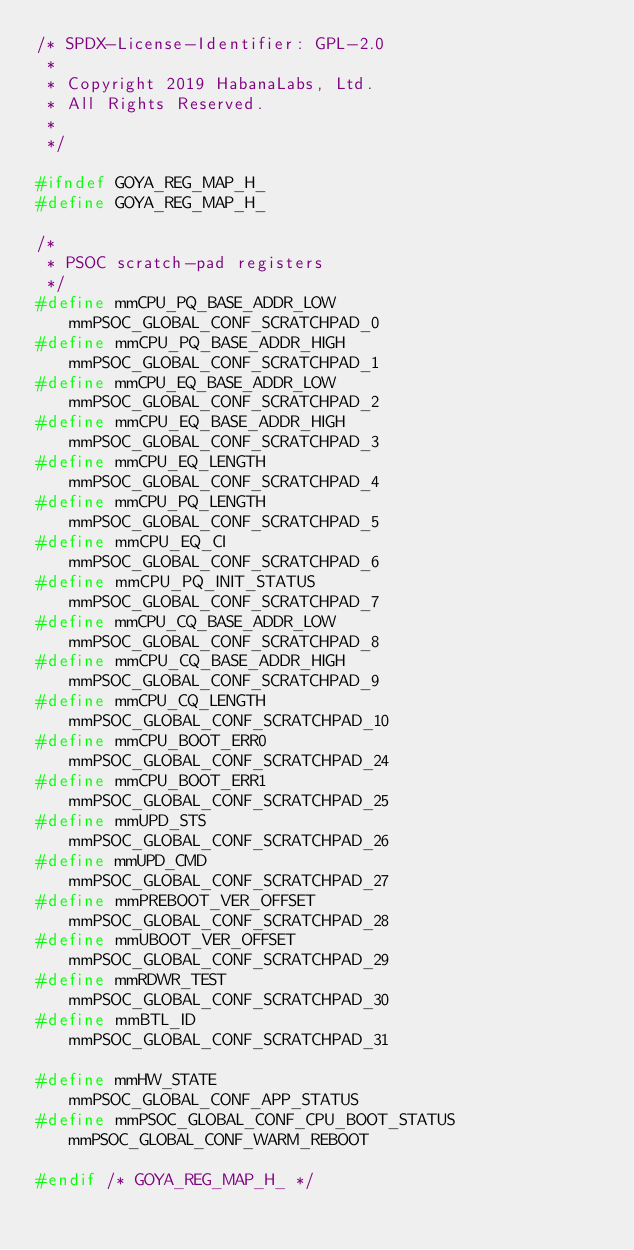<code> <loc_0><loc_0><loc_500><loc_500><_C_>/* SPDX-License-Identifier: GPL-2.0
 *
 * Copyright 2019 HabanaLabs, Ltd.
 * All Rights Reserved.
 *
 */

#ifndef GOYA_REG_MAP_H_
#define GOYA_REG_MAP_H_

/*
 * PSOC scratch-pad registers
 */
#define mmCPU_PQ_BASE_ADDR_LOW			mmPSOC_GLOBAL_CONF_SCRATCHPAD_0
#define mmCPU_PQ_BASE_ADDR_HIGH			mmPSOC_GLOBAL_CONF_SCRATCHPAD_1
#define mmCPU_EQ_BASE_ADDR_LOW			mmPSOC_GLOBAL_CONF_SCRATCHPAD_2
#define mmCPU_EQ_BASE_ADDR_HIGH			mmPSOC_GLOBAL_CONF_SCRATCHPAD_3
#define mmCPU_EQ_LENGTH				mmPSOC_GLOBAL_CONF_SCRATCHPAD_4
#define mmCPU_PQ_LENGTH				mmPSOC_GLOBAL_CONF_SCRATCHPAD_5
#define mmCPU_EQ_CI				mmPSOC_GLOBAL_CONF_SCRATCHPAD_6
#define mmCPU_PQ_INIT_STATUS			mmPSOC_GLOBAL_CONF_SCRATCHPAD_7
#define mmCPU_CQ_BASE_ADDR_LOW			mmPSOC_GLOBAL_CONF_SCRATCHPAD_8
#define mmCPU_CQ_BASE_ADDR_HIGH			mmPSOC_GLOBAL_CONF_SCRATCHPAD_9
#define mmCPU_CQ_LENGTH				mmPSOC_GLOBAL_CONF_SCRATCHPAD_10
#define mmCPU_BOOT_ERR0				mmPSOC_GLOBAL_CONF_SCRATCHPAD_24
#define mmCPU_BOOT_ERR1				mmPSOC_GLOBAL_CONF_SCRATCHPAD_25
#define mmUPD_STS				mmPSOC_GLOBAL_CONF_SCRATCHPAD_26
#define mmUPD_CMD				mmPSOC_GLOBAL_CONF_SCRATCHPAD_27
#define mmPREBOOT_VER_OFFSET			mmPSOC_GLOBAL_CONF_SCRATCHPAD_28
#define mmUBOOT_VER_OFFSET			mmPSOC_GLOBAL_CONF_SCRATCHPAD_29
#define mmRDWR_TEST				mmPSOC_GLOBAL_CONF_SCRATCHPAD_30
#define mmBTL_ID				mmPSOC_GLOBAL_CONF_SCRATCHPAD_31

#define mmHW_STATE				mmPSOC_GLOBAL_CONF_APP_STATUS
#define mmPSOC_GLOBAL_CONF_CPU_BOOT_STATUS	mmPSOC_GLOBAL_CONF_WARM_REBOOT

#endif /* GOYA_REG_MAP_H_ */
</code> 